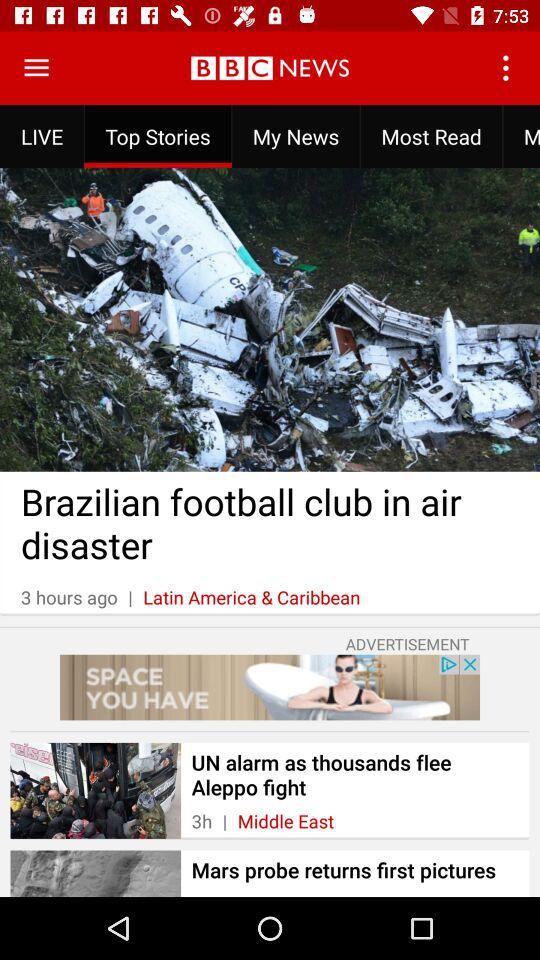How many stories are in the Middle East section?
Answer the question using a single word or phrase. 1 